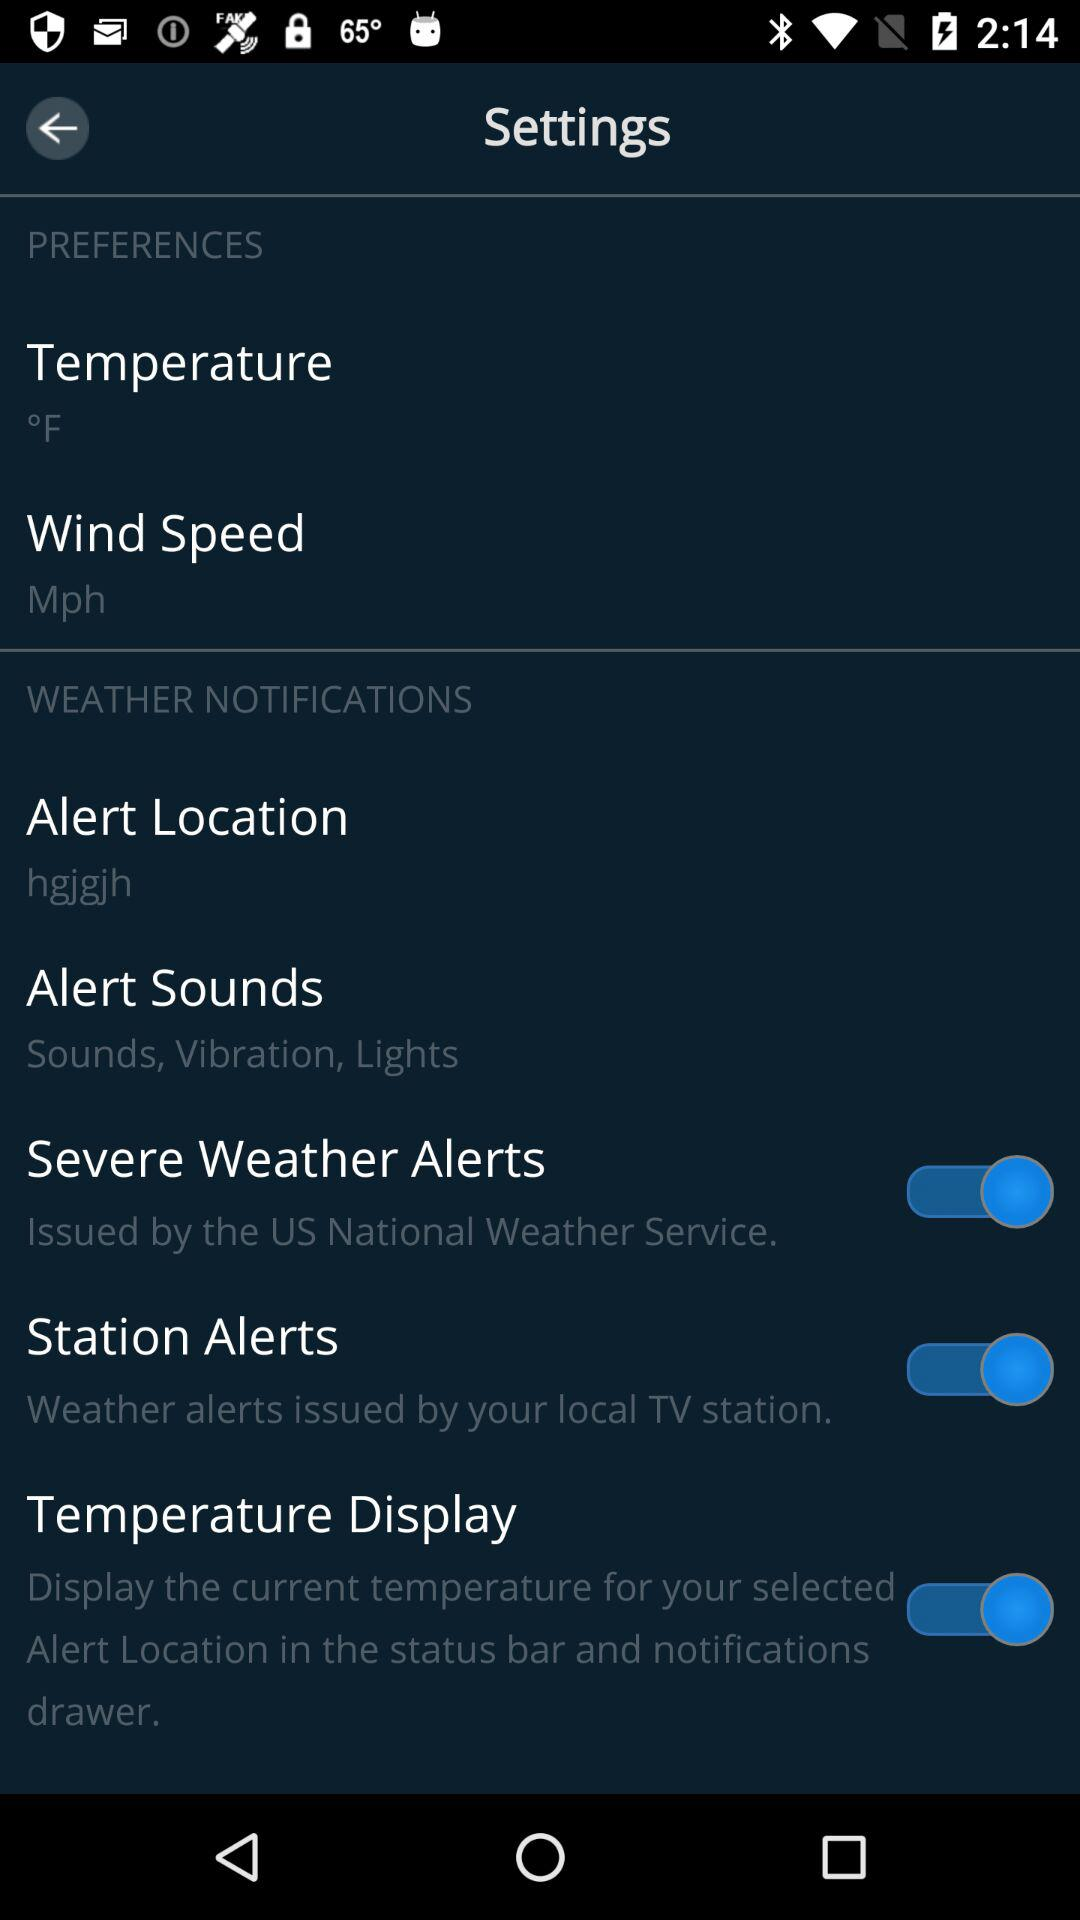How is the humidity measured?
When the provided information is insufficient, respond with <no answer>. <no answer> 